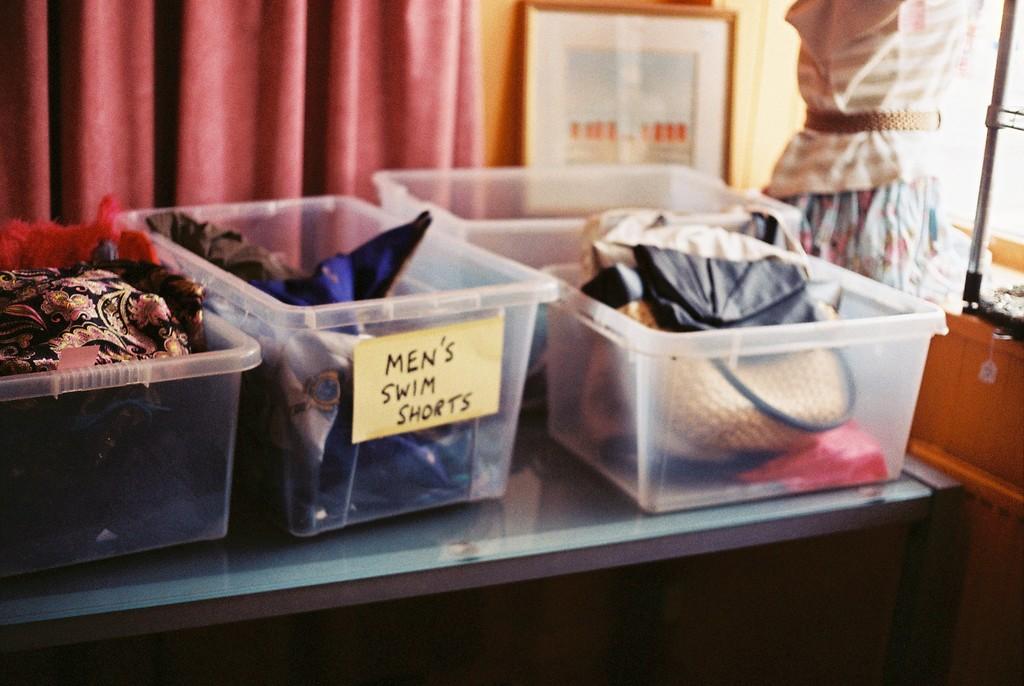What is being categorized in the middle bin?
Offer a terse response. Men's swim shorts. 